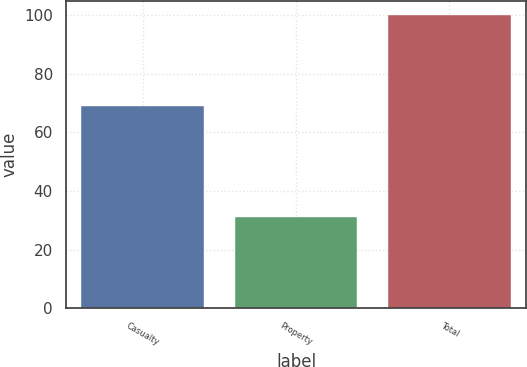<chart> <loc_0><loc_0><loc_500><loc_500><bar_chart><fcel>Casualty<fcel>Property<fcel>Total<nl><fcel>69<fcel>31<fcel>100<nl></chart> 